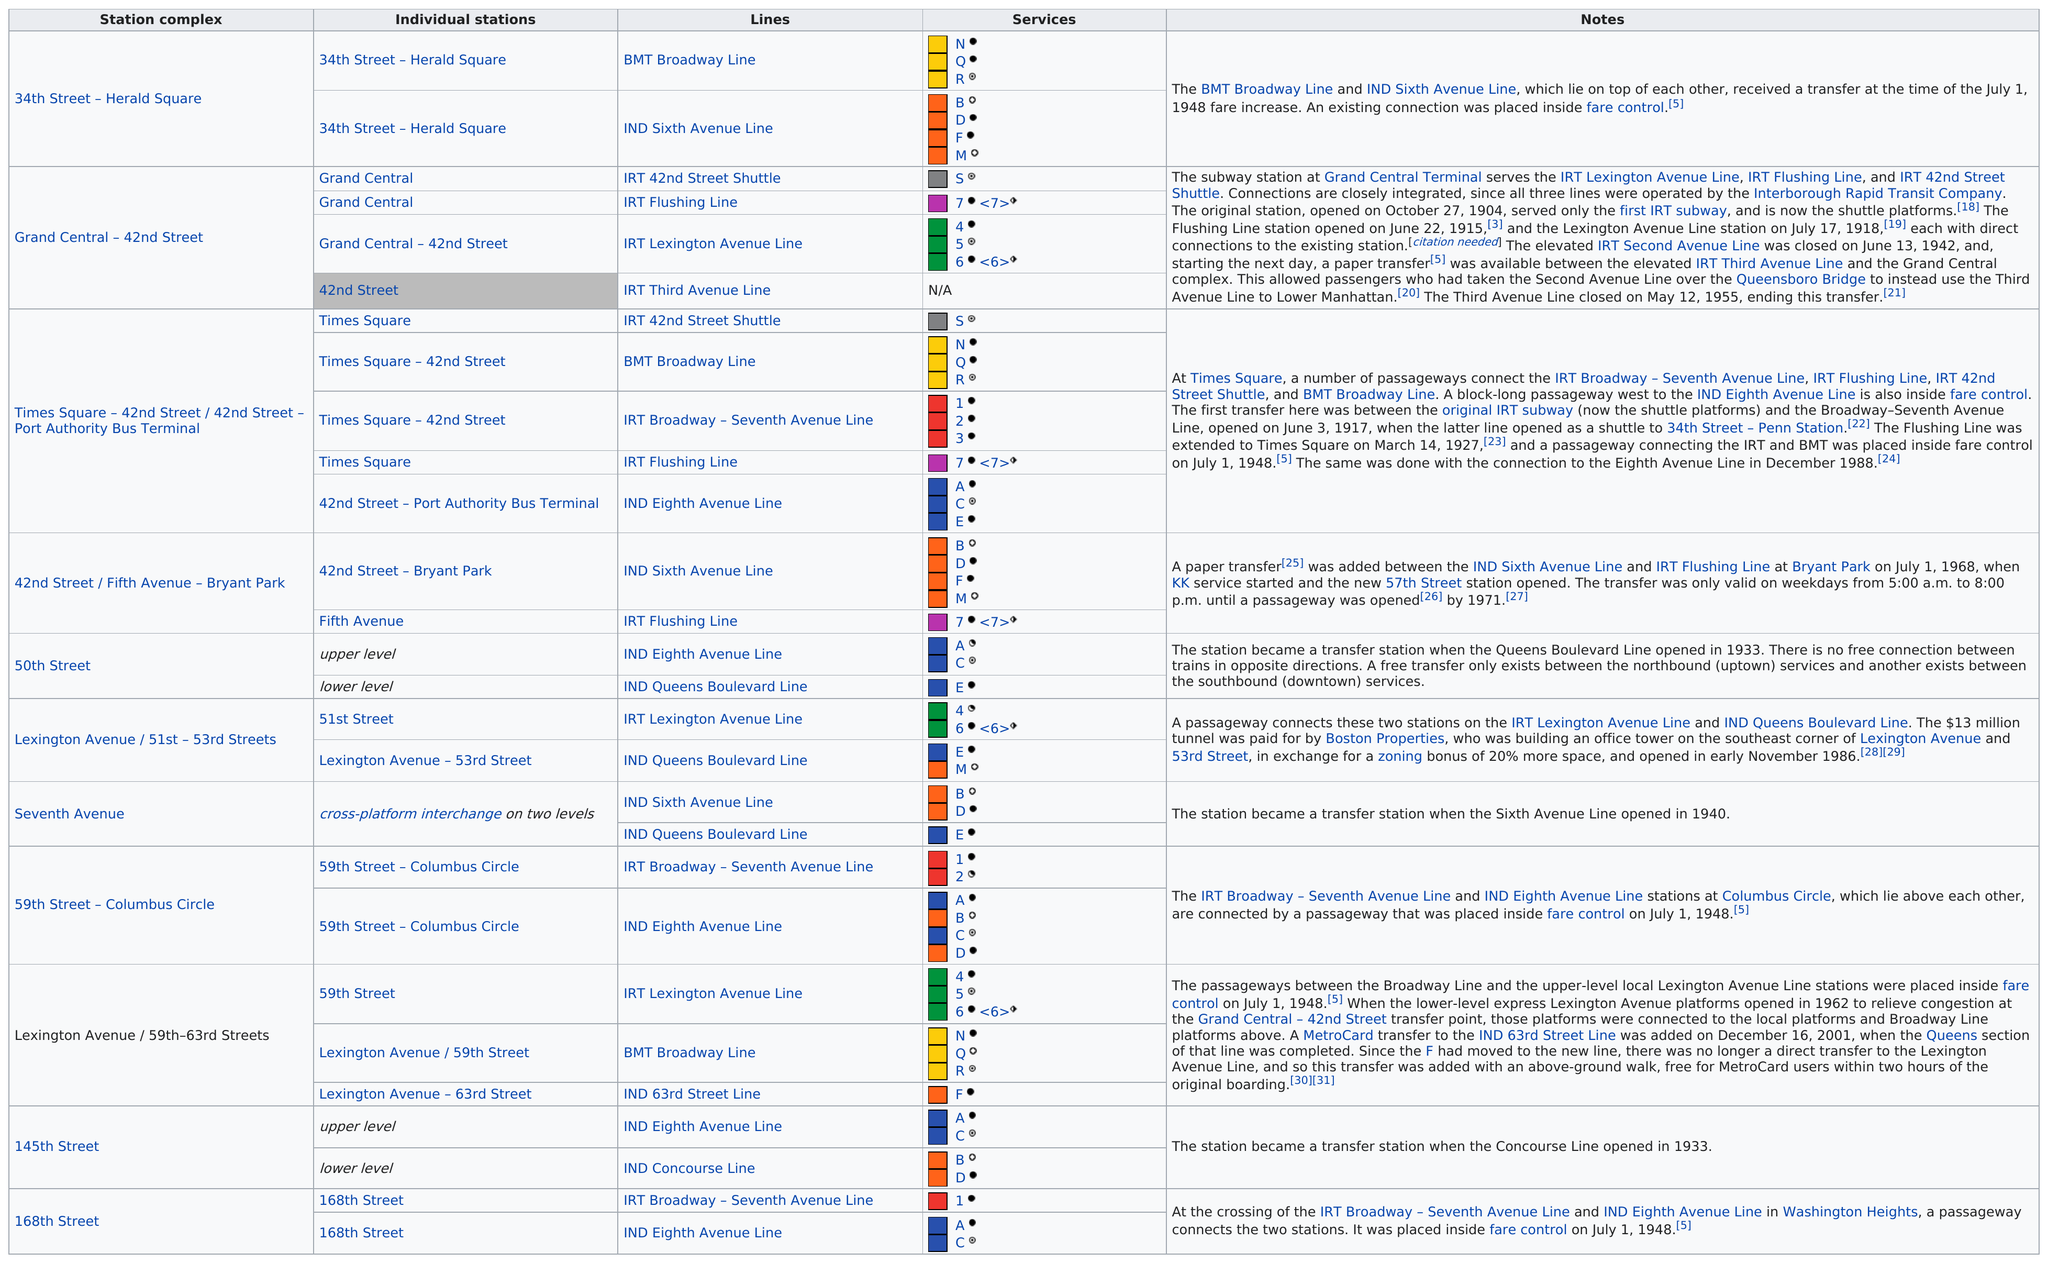Highlight a few significant elements in this photo. The number of services represented by yellow blocks was three. The station that does not provide any services is the 42nd Street station. There are 5 individual stations at the Times Square station complex. 